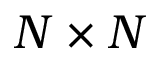Convert formula to latex. <formula><loc_0><loc_0><loc_500><loc_500>N \times N</formula> 